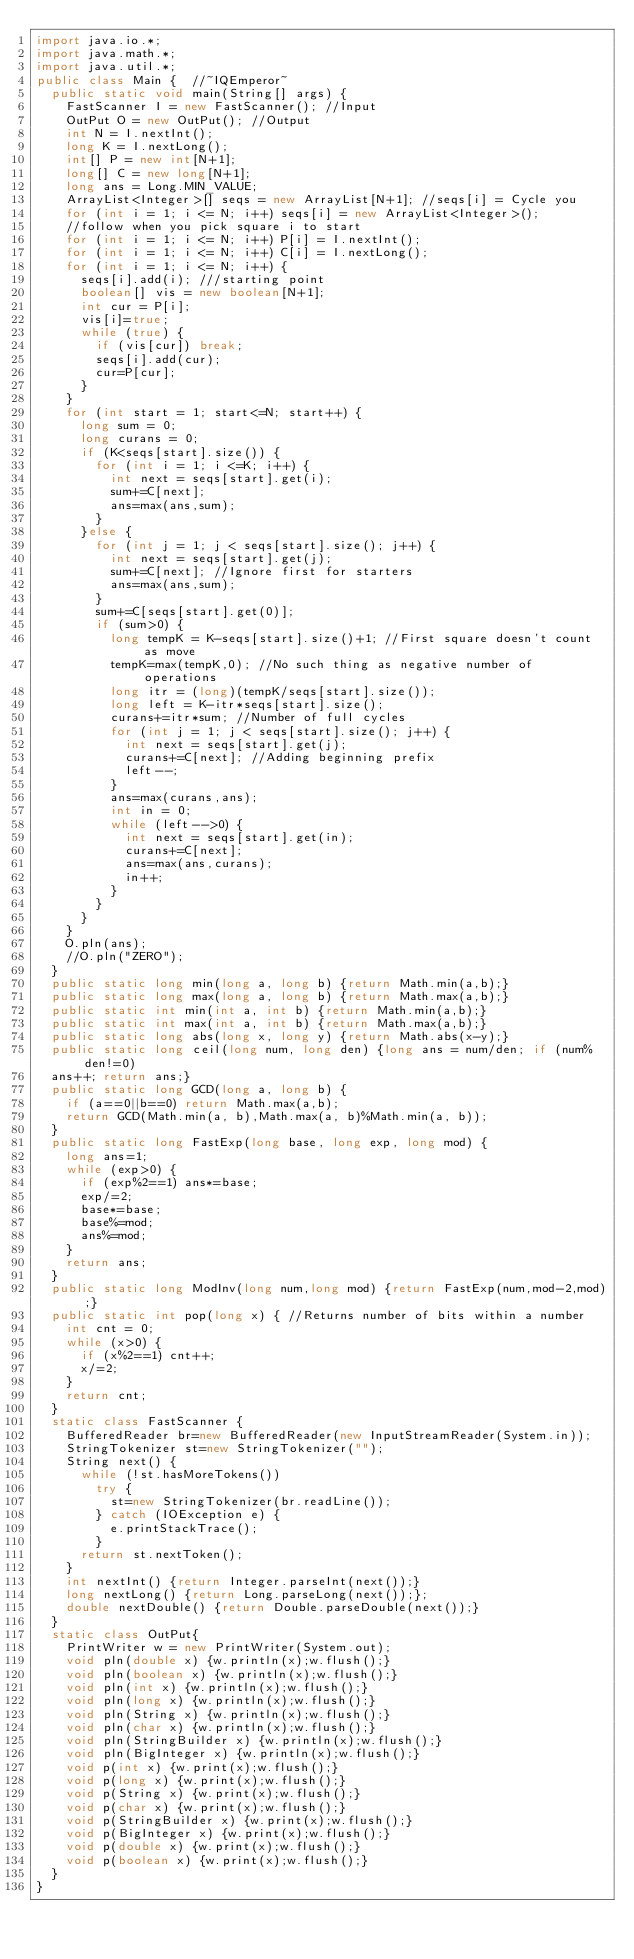Convert code to text. <code><loc_0><loc_0><loc_500><loc_500><_Java_>import java.io.*; 
import java.math.*;
import java.util.*;
public class Main {  //~IQEmperor~ 
	public static void main(String[] args) {
		FastScanner I = new FastScanner(); //Input
		OutPut O = new OutPut(); //Output
		int N = I.nextInt();
		long K = I.nextLong();
		int[] P = new int[N+1];
		long[] C = new long[N+1];
		long ans = Long.MIN_VALUE;
		ArrayList<Integer>[] seqs = new ArrayList[N+1]; //seqs[i] = Cycle you 
		for (int i = 1; i <= N; i++) seqs[i] = new ArrayList<Integer>();
		//follow when you pick square i to start
		for (int i = 1; i <= N; i++) P[i] = I.nextInt();
		for (int i = 1; i <= N; i++) C[i] = I.nextLong();
		for (int i = 1; i <= N; i++) {
			seqs[i].add(i); ///starting point
			boolean[] vis = new boolean[N+1];
			int cur = P[i];
			vis[i]=true;
			while (true) {
				if (vis[cur]) break;
				seqs[i].add(cur);
				cur=P[cur];
			}
		}
		for (int start = 1; start<=N; start++) {
			long sum = 0;
			long curans = 0;
			if (K<seqs[start].size()) {
				for (int i = 1; i <=K; i++) {
					int next = seqs[start].get(i);
					sum+=C[next];
					ans=max(ans,sum);
				} 
			}else {
				for (int j = 1; j < seqs[start].size(); j++) {
					int next = seqs[start].get(j);
					sum+=C[next]; //Ignore first for starters
					ans=max(ans,sum);
				}
				sum+=C[seqs[start].get(0)];
				if (sum>0) {
					long tempK = K-seqs[start].size()+1; //First square doesn't count as move
					tempK=max(tempK,0); //No such thing as negative number of operations
					long itr = (long)(tempK/seqs[start].size());
					long left = K-itr*seqs[start].size();
					curans+=itr*sum; //Number of full cycles
					for (int j = 1; j < seqs[start].size(); j++) {
						int next = seqs[start].get(j);
						curans+=C[next]; //Adding beginning prefix
						left--;
					}
					ans=max(curans,ans);
					int in = 0;
					while (left-->0) {
						int next = seqs[start].get(in);
						curans+=C[next];
						ans=max(ans,curans);
						in++;
					}
				}
			}
		}
		O.pln(ans);
		//O.pln("ZERO");
	}
	public static long min(long a, long b) {return Math.min(a,b);}
	public static long max(long a, long b) {return Math.max(a,b);}
	public static int min(int a, int b) {return Math.min(a,b);}
	public static int max(int a, int b) {return Math.max(a,b);}
	public static long abs(long x, long y) {return Math.abs(x-y);}
	public static long ceil(long num, long den) {long ans = num/den; if (num%den!=0) 
	ans++; return ans;}
	public static long GCD(long a, long b) {
		if (a==0||b==0) return Math.max(a,b);
		return GCD(Math.min(a, b),Math.max(a, b)%Math.min(a, b));
	}
	public static long FastExp(long base, long exp, long mod) {
		long ans=1;
		while (exp>0) {
			if (exp%2==1) ans*=base;
			exp/=2;
			base*=base;
			base%=mod;
			ans%=mod;
		}
		return ans;
	}
	public static long ModInv(long num,long mod) {return FastExp(num,mod-2,mod);}
	public static int pop(long x) { //Returns number of bits within a number
		int cnt = 0;
		while (x>0) {
			if (x%2==1) cnt++;
			x/=2;
		}
		return cnt;
	}
	static class FastScanner {
		BufferedReader br=new BufferedReader(new InputStreamReader(System.in));
		StringTokenizer st=new StringTokenizer("");
		String next() {
			while (!st.hasMoreTokens())
				try {
					st=new StringTokenizer(br.readLine());
				} catch (IOException e) {
					e.printStackTrace();
				}
			return st.nextToken();
		}
		int nextInt() {return Integer.parseInt(next());}
		long nextLong() {return Long.parseLong(next());};
		double nextDouble() {return Double.parseDouble(next());}
	}
	static class OutPut{
		PrintWriter w = new PrintWriter(System.out);
		void pln(double x) {w.println(x);w.flush();}
		void pln(boolean x) {w.println(x);w.flush();}
		void pln(int x) {w.println(x);w.flush();}
		void pln(long x) {w.println(x);w.flush();}
		void pln(String x) {w.println(x);w.flush();}
		void pln(char x) {w.println(x);w.flush();}
		void pln(StringBuilder x) {w.println(x);w.flush();}
		void pln(BigInteger x) {w.println(x);w.flush();}
		void p(int x) {w.print(x);w.flush();}
		void p(long x) {w.print(x);w.flush();}
		void p(String x) {w.print(x);w.flush();}
		void p(char x) {w.print(x);w.flush();}
		void p(StringBuilder x) {w.print(x);w.flush();}
		void p(BigInteger x) {w.print(x);w.flush();}
		void p(double x) {w.print(x);w.flush();}
		void p(boolean x) {w.print(x);w.flush();}
	}
}</code> 